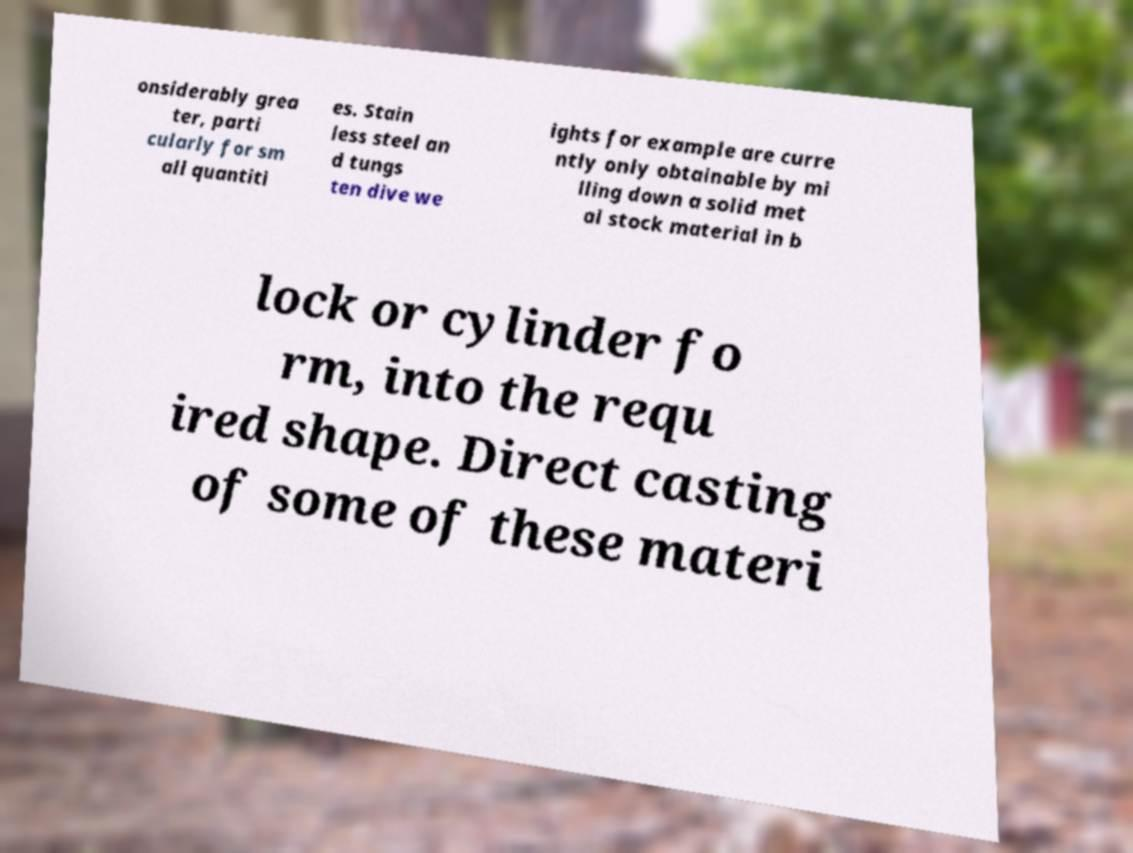Could you assist in decoding the text presented in this image and type it out clearly? onsiderably grea ter, parti cularly for sm all quantiti es. Stain less steel an d tungs ten dive we ights for example are curre ntly only obtainable by mi lling down a solid met al stock material in b lock or cylinder fo rm, into the requ ired shape. Direct casting of some of these materi 